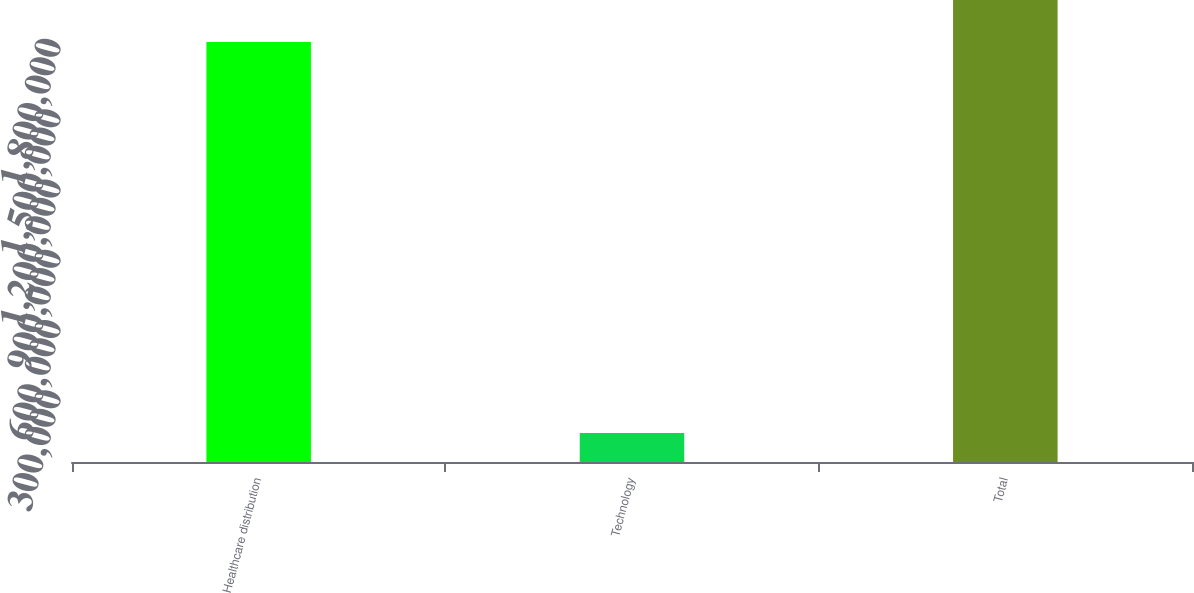Convert chart to OTSL. <chart><loc_0><loc_0><loc_500><loc_500><bar_chart><fcel>Healthcare distribution<fcel>Technology<fcel>Total<nl><fcel>1.79252e+06<fcel>124304<fcel>1.97177e+06<nl></chart> 